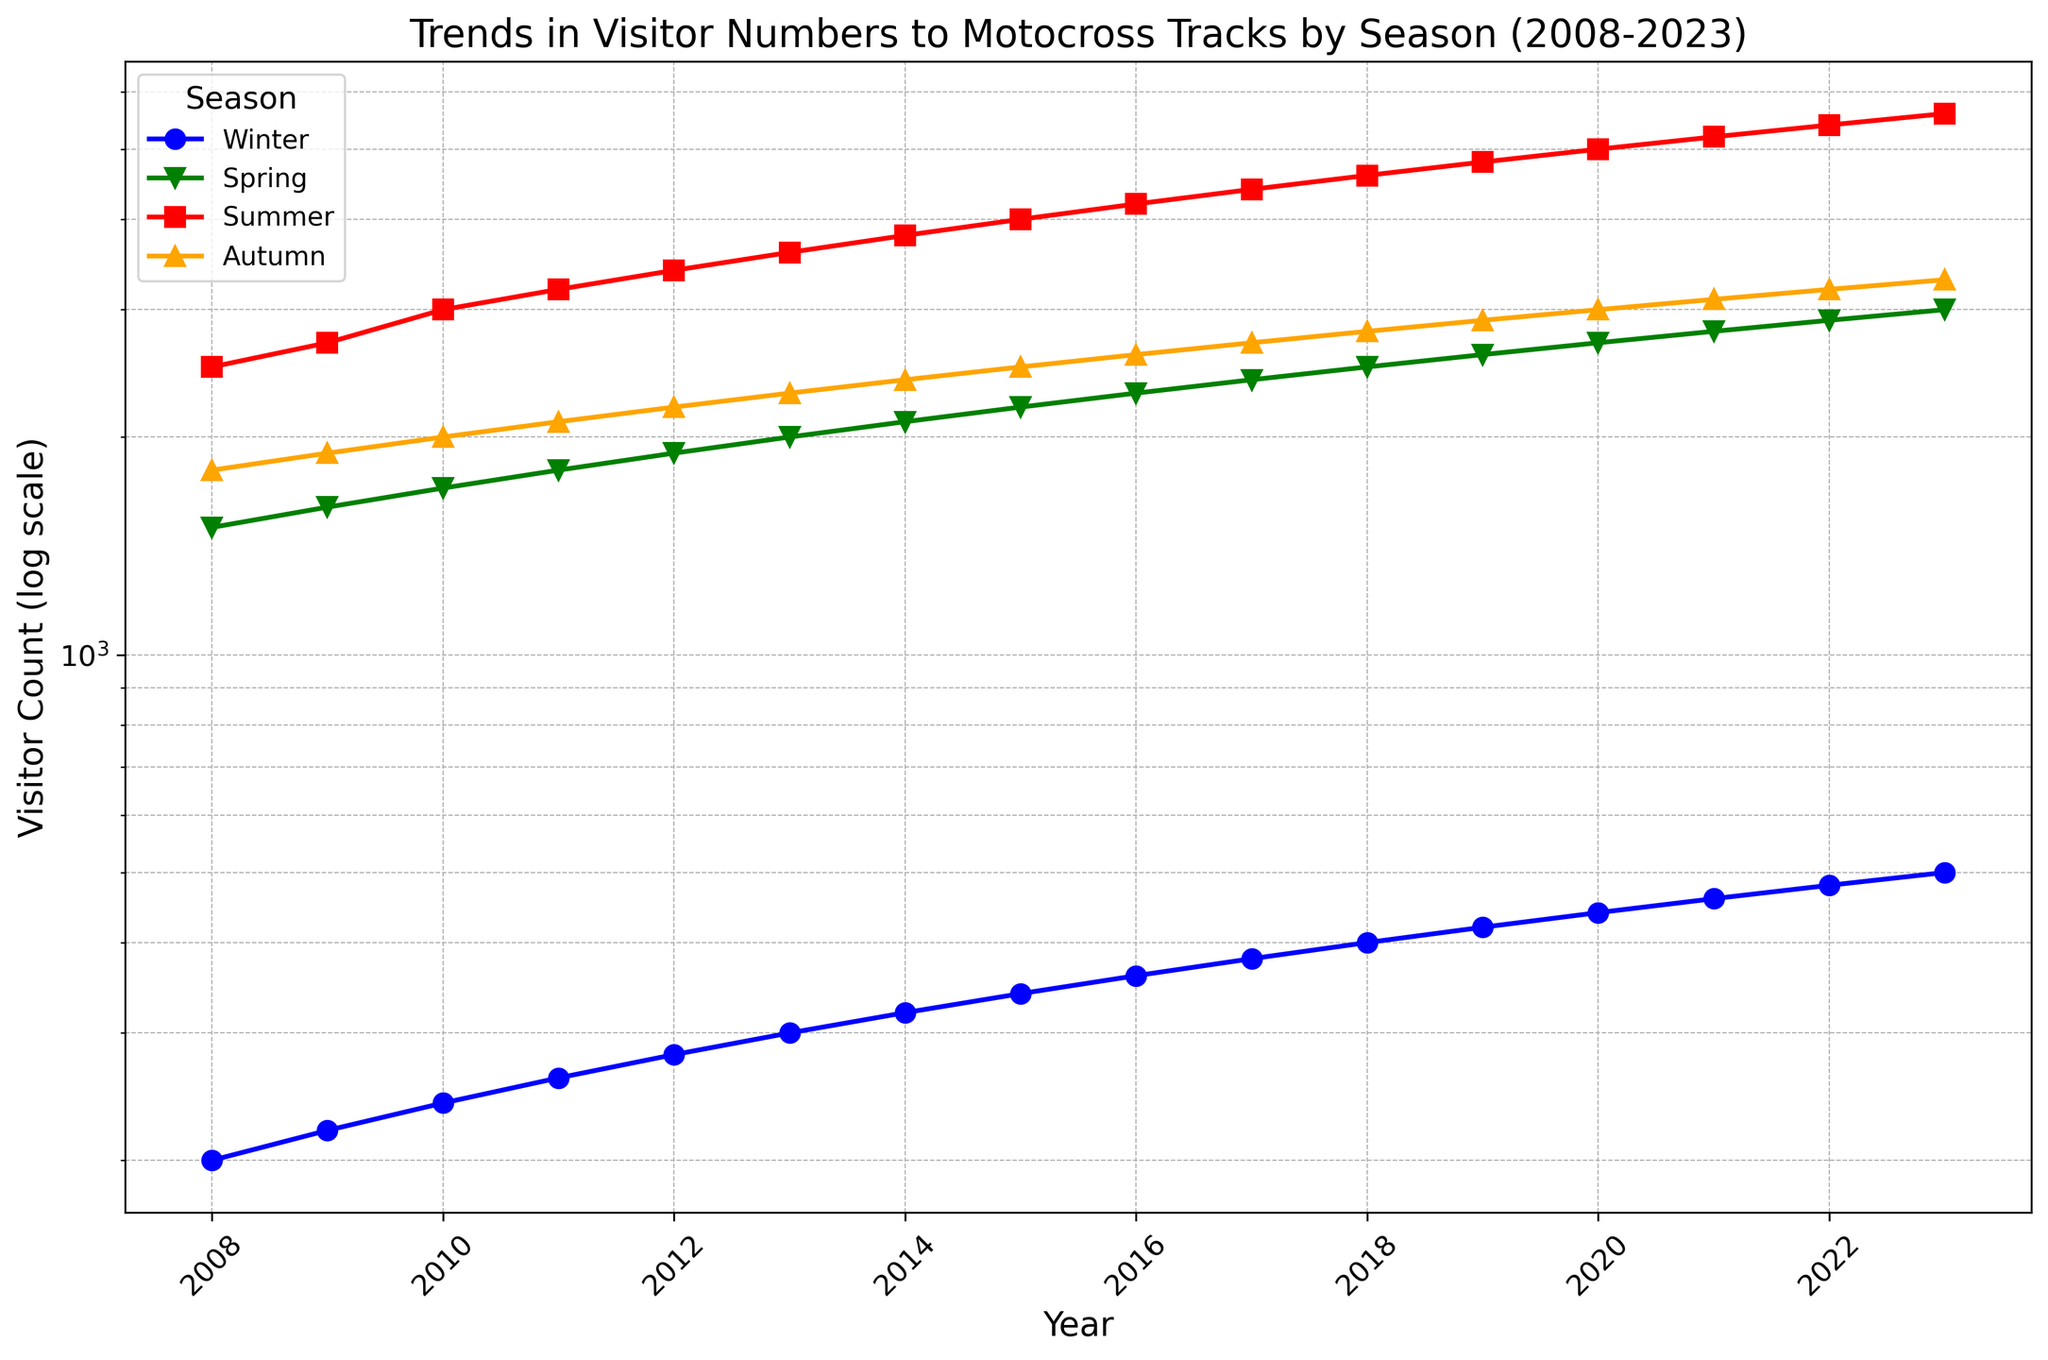What's the overall trend in visitor numbers for all seasons from 2008 to 2023? The plot shows an upward trend for all seasons from 2008 to 2023. Although there are seasonal fluctuations, the general trajectory for visitor numbers is increasing. Specifically, both winter and summer seasons show a significant rise in visitor counts over the years.
Answer: Increasing In which year did the summer season first surpass 5000 visitors? Looking at the logscale chart, the plotted line for summer reaches 5000 visitors in the year 2020. The visitor count for the summer season continues to increase in subsequent years.
Answer: 2020 Which season consistently has the highest visitor count? The summer season consistently has the highest visitor count throughout all the years. This can be observed from the red line, which always appears at the top of the chart compared to other seasonal lines.
Answer: Summer Compare the visitor count difference between autumn and winter in the year 2010. In 2010, the chart shows that autumn had a visitor count of 2000 while winter had a visitor count of 240. The difference is calculated by subtracting the winter visitor count from the autumn visitor count: 2000 - 240 = 1760.
Answer: 1760 Which year shows the smallest gap between spring and autumn visitor counts? By observing the distance between the green (spring) and orange (autumn) lines on the chart, it can be seen that the smallest gap appears around 2022, where spring visitor numbers are 2900 and autumn visitor numbers are 3200. The gap is: 3200 - 2900 = 300.
Answer: 2022 What is the average visitor count for winter over the 15 years? Sum the winter visitor counts from 2008 to 2023 and then divide by the number of years (16): (200 + 220 + 240 + 260 + 280 + 300 + 320 + 340 + 360 + 380 + 400 + 420 + 440 + 460 + 480 + 500) / 16 = 3660 / 16 = 366.25
Answer: 366.25 Which season shows the most noticeable increase in visitor count between 2010 and 2020? By observing the slope of each seasonal line between 2010 and 2020, the summer season (red line) shows the most noticeable increase in visitor count. The number rises from around 3000 in 2010 to 5000 in 2020.
Answer: Summer What is the median visitor count for the spring season from 2008 to 2023? The visitor counts for spring season from 2008 to 2023 are listed as: 1500, 1600, 1700, 1800, 1900, 2000, 2100, 2200, 2300, 2400, 2500, 2600, 2700, 2800, 2900, 3000. Ordering these and finding the median (average of the 8th and 9th values, as there are 16 data points): Median = (2200 + 2300) / 2 = 2250.
Answer: 2250 